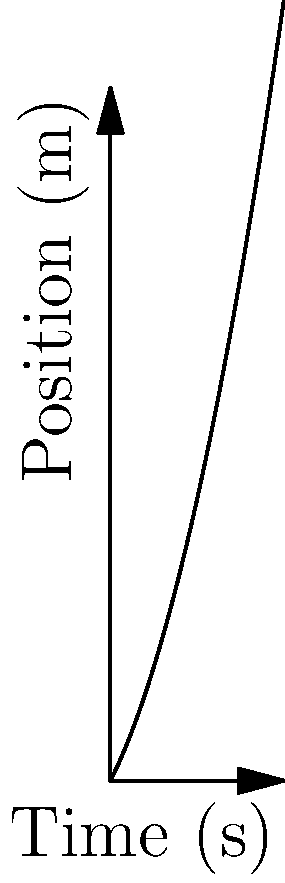As a sports reporter covering a hockey game at Nassau Coliseum, you're analyzing the movement of a puck. The position-time graph of the puck's motion along a straight line is shown above. Calculate the puck's velocity at t = 3 seconds. To find the velocity at a specific point in time, we need to calculate the derivative of the position function at that point. Here's how we can do this:

1) From the graph, we can see that the position function appears to be quadratic. Let's assume it has the form:
   $$s(t) = at^2 + bt + c$$

2) We can determine the coefficients by observing the graph:
   - When t = 0, s ≈ 2, so c = 2
   - The graph passes through (1, 4.5) and (2, 9), which gives us two equations:
     $$4.5 = a + b + 2$$
     $$9 = 4a + 2b + 2$$

3) Solving these equations, we get:
   $$s(t) = 0.5t^2 + 2t + 2$$

4) The velocity is the derivative of the position function:
   $$v(t) = \frac{d}{dt}s(t) = t + 2$$

5) At t = 3 seconds:
   $$v(3) = 3 + 2 = 5$$

Therefore, the velocity of the puck at t = 3 seconds is 5 m/s.
Answer: 5 m/s 